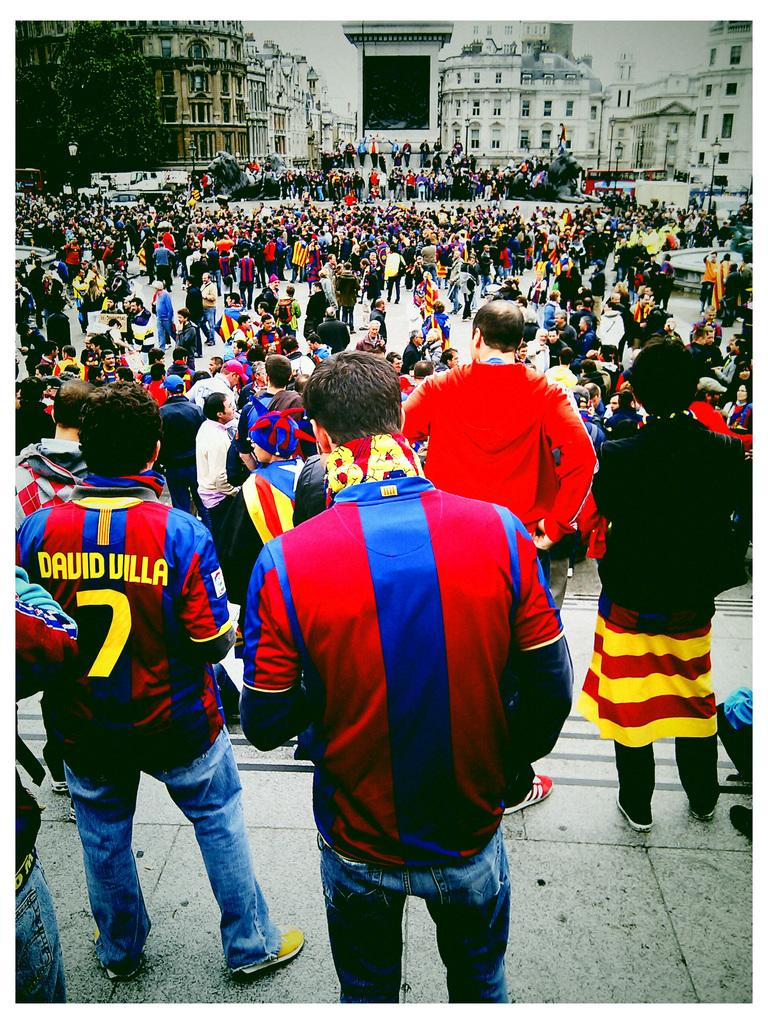What can be seen in the image? There are people standing in the image, along with buildings and trees. Can you describe the people in the image? The provided facts do not give specific details about the people, so we cannot describe them further. What type of structures are visible in the image? There are buildings in the image. What kind of vegetation is present in the image? There are trees in the image. Are there any servants attending to the people in the image? There is no mention of servants in the provided facts, so we cannot determine if there are any in the image. What type of clover can be seen growing near the trees in the image? There is no mention of clover in the provided facts, so we cannot determine if there is any in the image. 